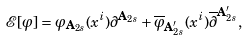<formula> <loc_0><loc_0><loc_500><loc_500>\mathcal { E } [ \varphi ] = \varphi _ { \mathbf A _ { 2 s } } ( x ^ { i } ) \partial ^ { \mathbf A _ { 2 s } } + \overline { \varphi } _ { \mathbf A _ { 2 s } ^ { \prime } } ( x ^ { i } ) \overline { \partial } ^ { \mathbf A _ { 2 s } ^ { \prime } } ,</formula> 